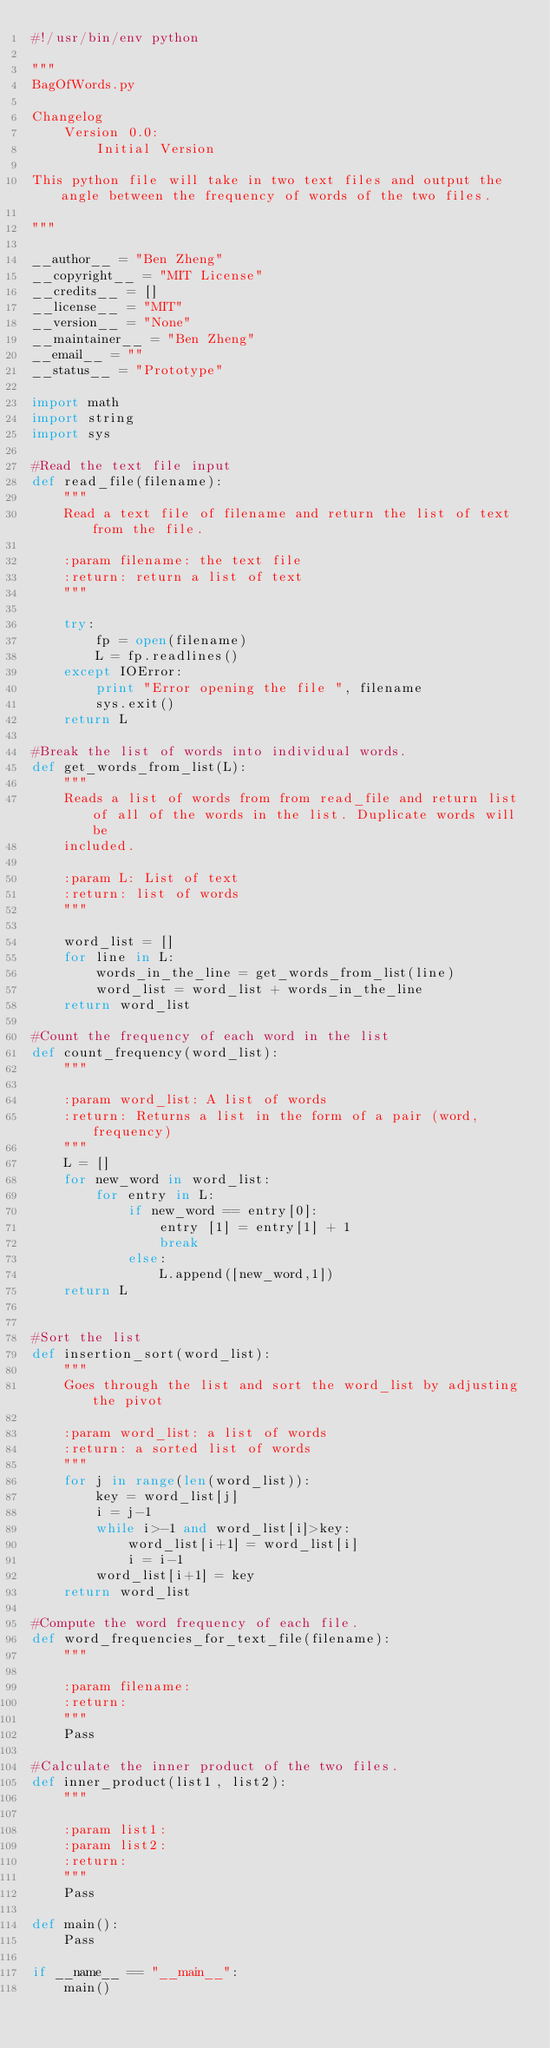<code> <loc_0><loc_0><loc_500><loc_500><_Python_>#!/usr/bin/env python

"""
BagOfWords.py

Changelog
    Version 0.0:
        Initial Version

This python file will take in two text files and output the angle between the frequency of words of the two files.

"""

__author__ = "Ben Zheng"
__copyright__ = "MIT License"
__credits__ = []
__license__ = "MIT"
__version__ = "None"
__maintainer__ = "Ben Zheng"
__email__ = ""
__status__ = "Prototype"

import math
import string
import sys

#Read the text file input
def read_file(filename):
    """
    Read a text file of filename and return the list of text from the file.

    :param filename: the text file
    :return: return a list of text
    """

    try:
        fp = open(filename)
        L = fp.readlines()
    except IOError:
        print "Error opening the file ", filename
        sys.exit()
    return L

#Break the list of words into individual words.
def get_words_from_list(L):
    """
    Reads a list of words from from read_file and return list of all of the words in the list. Duplicate words will be
    included.

    :param L: List of text
    :return: list of words
    """

    word_list = []
    for line in L:
        words_in_the_line = get_words_from_list(line)
        word_list = word_list + words_in_the_line
    return word_list

#Count the frequency of each word in the list
def count_frequency(word_list):
    """

    :param word_list: A list of words
    :return: Returns a list in the form of a pair (word, frequency)
    """
    L = []
    for new_word in word_list:
        for entry in L:
            if new_word == entry[0]:
                entry [1] = entry[1] + 1
                break
            else:
                L.append([new_word,1])
    return L


#Sort the list
def insertion_sort(word_list):
    """
    Goes through the list and sort the word_list by adjusting the pivot

    :param word_list: a list of words
    :return: a sorted list of words
    """
    for j in range(len(word_list)):
        key = word_list[j]
        i = j-1
        while i>-1 and word_list[i]>key:
            word_list[i+1] = word_list[i]
            i = i-1
        word_list[i+1] = key
    return word_list

#Compute the word frequency of each file.
def word_frequencies_for_text_file(filename):
    """

    :param filename:
    :return:
    """
    Pass

#Calculate the inner product of the two files.
def inner_product(list1, list2):
    """

    :param list1:
    :param list2:
    :return:
    """
    Pass

def main():
    Pass

if __name__ == "__main__":
    main()</code> 